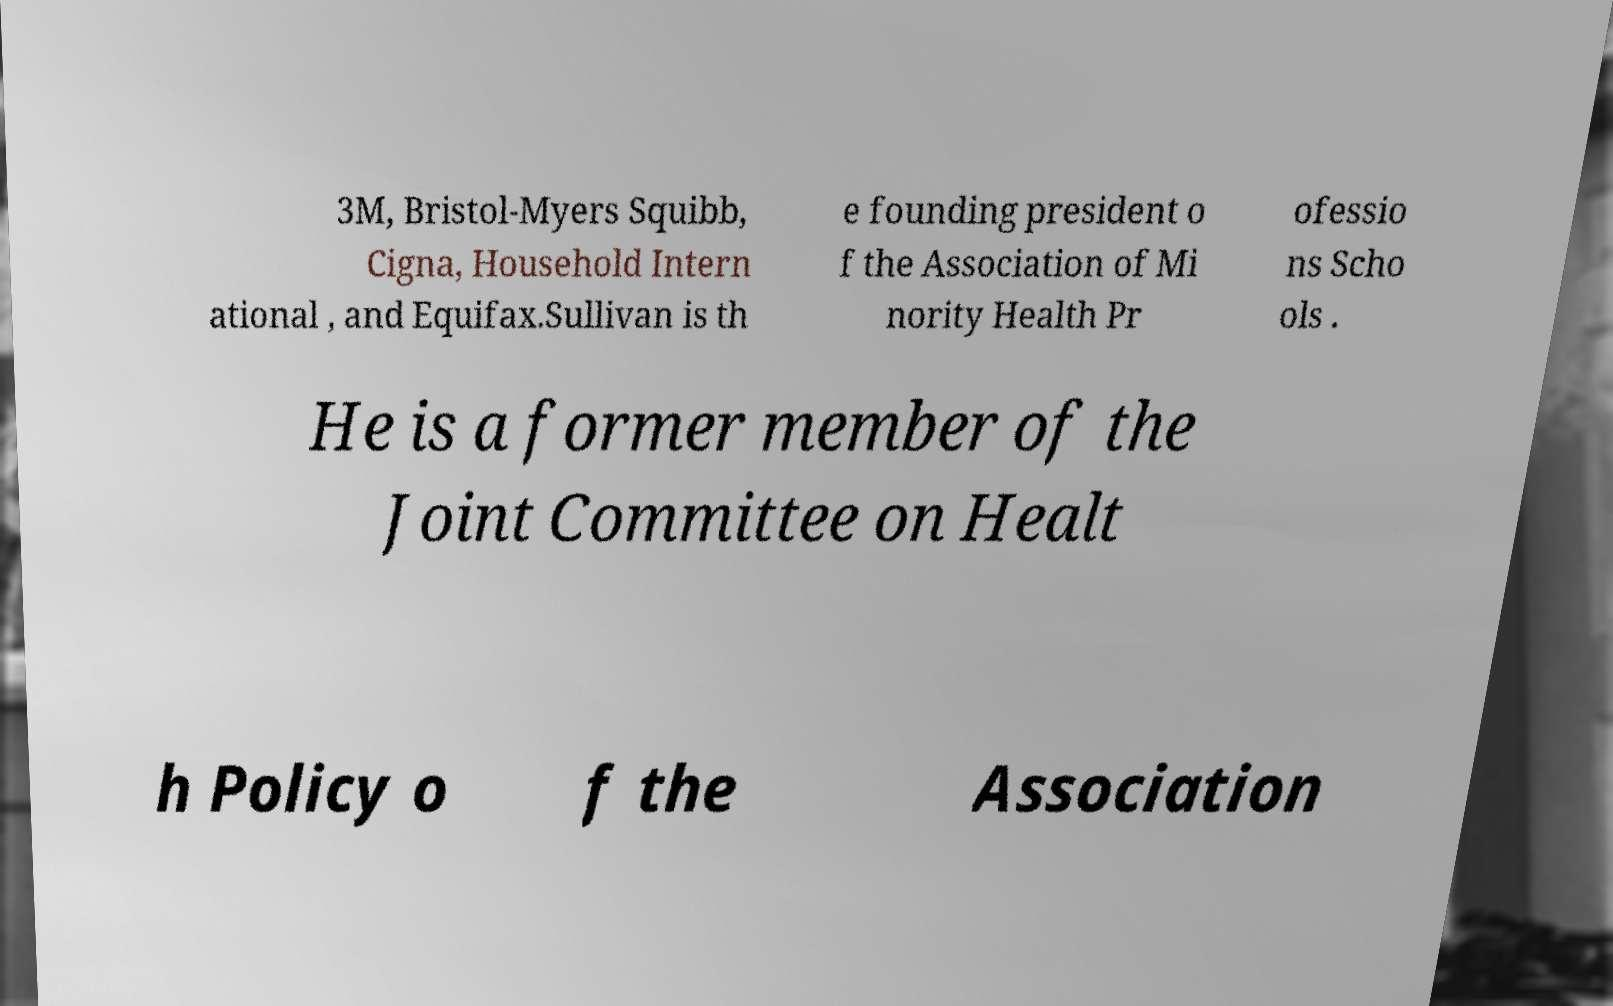Can you read and provide the text displayed in the image?This photo seems to have some interesting text. Can you extract and type it out for me? 3M, Bristol-Myers Squibb, Cigna, Household Intern ational , and Equifax.Sullivan is th e founding president o f the Association of Mi nority Health Pr ofessio ns Scho ols . He is a former member of the Joint Committee on Healt h Policy o f the Association 